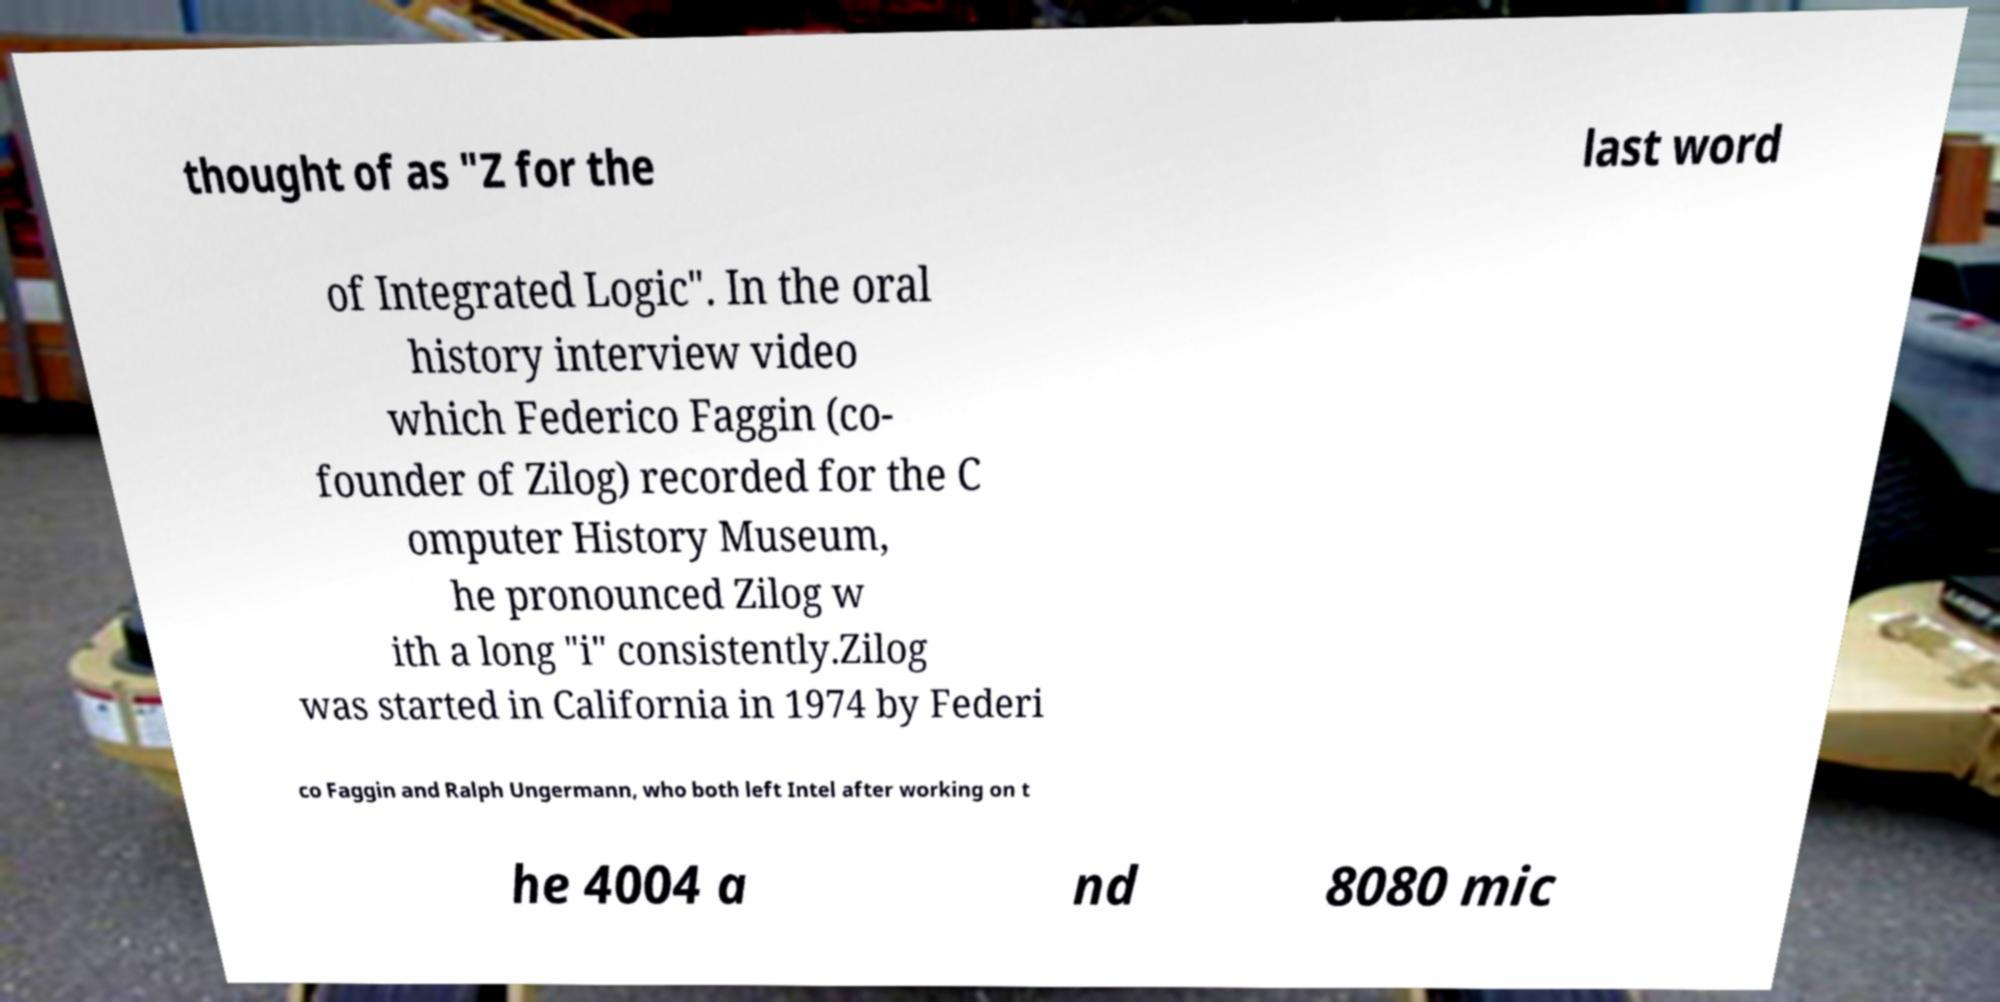For documentation purposes, I need the text within this image transcribed. Could you provide that? thought of as "Z for the last word of Integrated Logic". In the oral history interview video which Federico Faggin (co- founder of Zilog) recorded for the C omputer History Museum, he pronounced Zilog w ith a long "i" consistently.Zilog was started in California in 1974 by Federi co Faggin and Ralph Ungermann, who both left Intel after working on t he 4004 a nd 8080 mic 